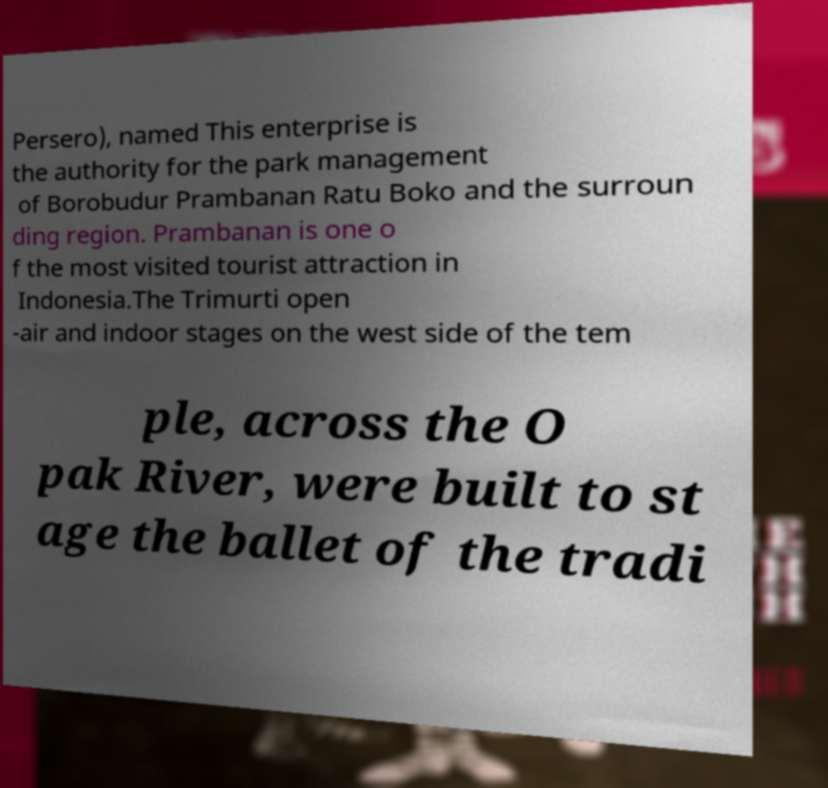Could you extract and type out the text from this image? Persero), named This enterprise is the authority for the park management of Borobudur Prambanan Ratu Boko and the surroun ding region. Prambanan is one o f the most visited tourist attraction in Indonesia.The Trimurti open -air and indoor stages on the west side of the tem ple, across the O pak River, were built to st age the ballet of the tradi 